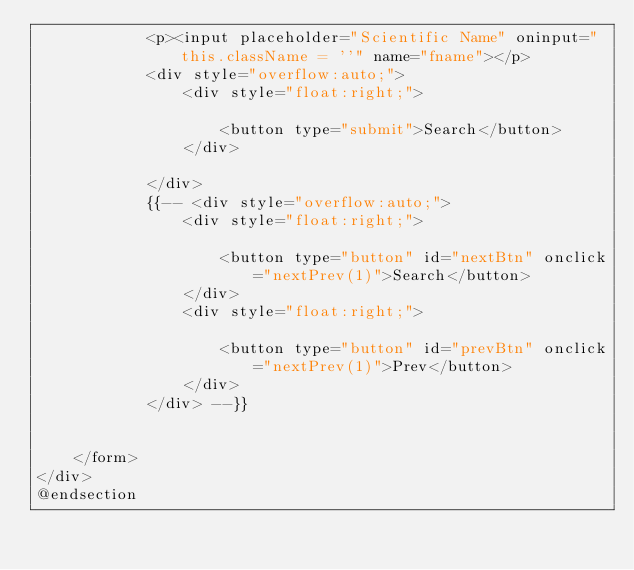<code> <loc_0><loc_0><loc_500><loc_500><_PHP_>            <p><input placeholder="Scientific Name" oninput="this.className = ''" name="fname"></p>
            <div style="overflow:auto;">
                <div style="float:right;">

                    <button type="submit">Search</button>
                </div>

            </div>
            {{-- <div style="overflow:auto;">
                <div style="float:right;">

                    <button type="button" id="nextBtn" onclick="nextPrev(1)">Search</button>
                </div>
                <div style="float:right;">

                    <button type="button" id="prevBtn" onclick="nextPrev(1)">Prev</button>
                </div>
            </div> --}}


    </form>
</div>
@endsection</code> 